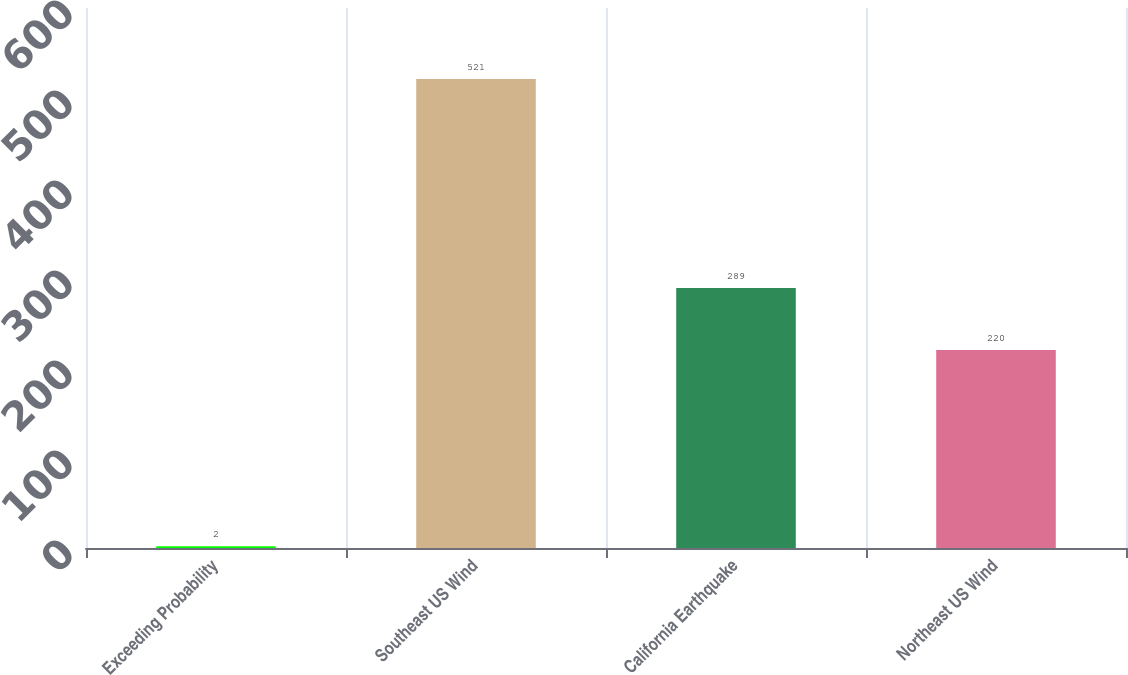Convert chart to OTSL. <chart><loc_0><loc_0><loc_500><loc_500><bar_chart><fcel>Exceeding Probability<fcel>Southeast US Wind<fcel>California Earthquake<fcel>Northeast US Wind<nl><fcel>2<fcel>521<fcel>289<fcel>220<nl></chart> 